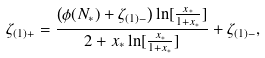Convert formula to latex. <formula><loc_0><loc_0><loc_500><loc_500>\zeta _ { ( 1 ) + } = \frac { \left ( \phi ( N _ { * } ) + \zeta _ { ( 1 ) - } \right ) \ln [ { \frac { x _ { * } } { 1 + x _ { * } } } ] } { 2 + x _ { * } \ln [ \frac { x _ { * } } { 1 + x _ { * } } ] } + \zeta _ { ( 1 ) - } ,</formula> 